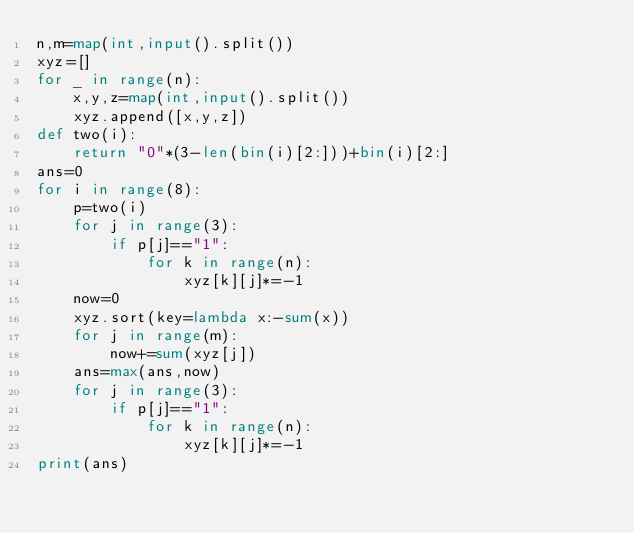Convert code to text. <code><loc_0><loc_0><loc_500><loc_500><_Python_>n,m=map(int,input().split())
xyz=[]
for _ in range(n):
	x,y,z=map(int,input().split())
	xyz.append([x,y,z])
def two(i):
	return "0"*(3-len(bin(i)[2:]))+bin(i)[2:]
ans=0
for i in range(8):
	p=two(i)
	for j in range(3):
		if p[j]=="1":
			for k in range(n):
				xyz[k][j]*=-1
	now=0
	xyz.sort(key=lambda x:-sum(x))
	for j in range(m):
		now+=sum(xyz[j])
	ans=max(ans,now)
	for j in range(3):
		if p[j]=="1":
			for k in range(n):
				xyz[k][j]*=-1
print(ans)</code> 